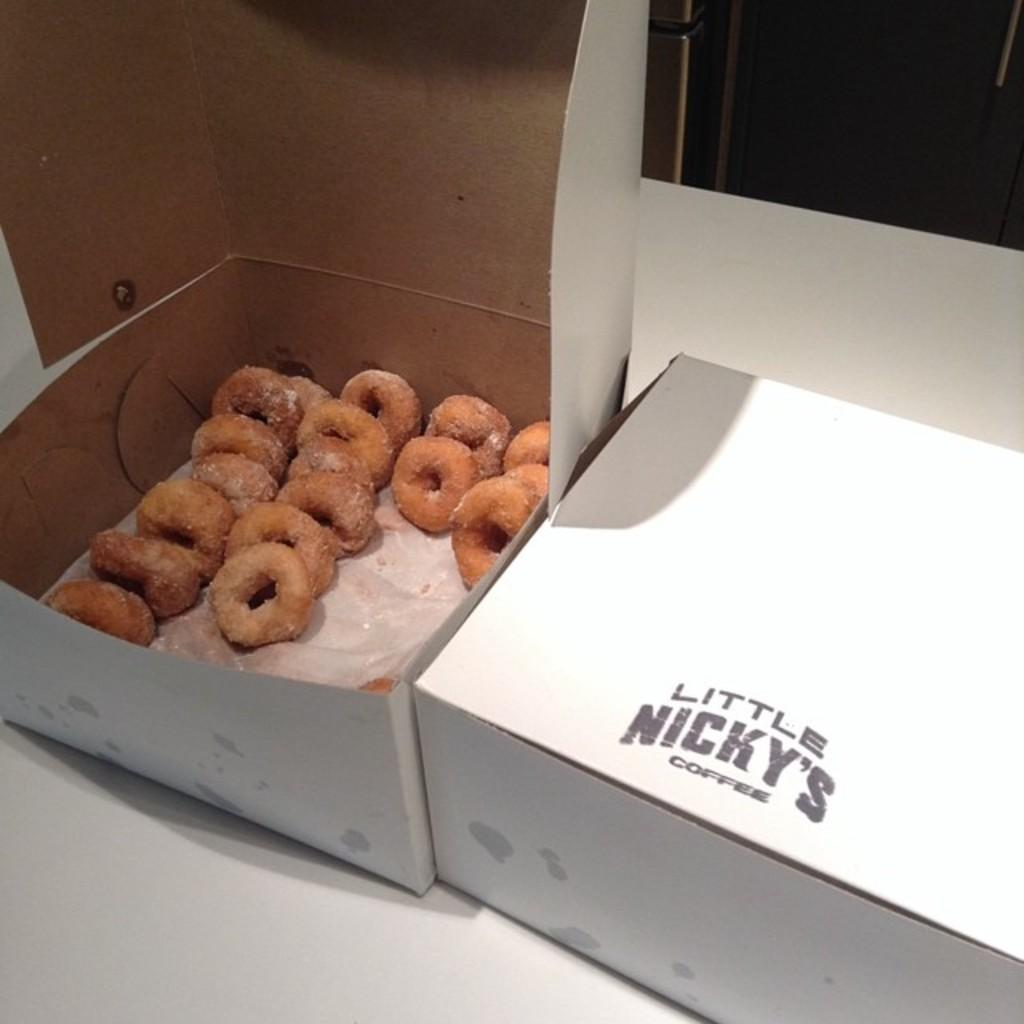What objects are on the table in the image? There are boxes on a table in the image. Can you describe the state of the boxes? One box is opened and contains a food item, while another box is closed. What information can be gathered from the closed box? There is text on the closed box. How many beans are visible in the image? There is no mention of beans in the image, so it is impossible to determine their presence or quantity. 